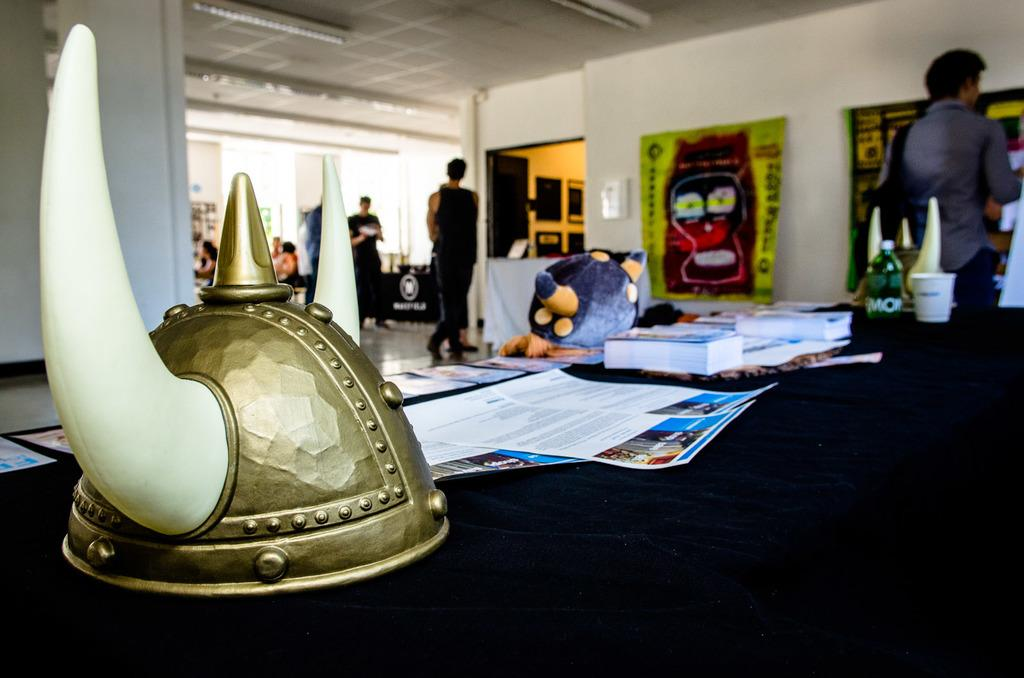What type of hat is in the image? There is a hat with two horns in the image. Where is the hat located? The hat is placed on a table. What other items can be seen on the table? There are books, papers, a bottle, and a cup on the table. Are there any people visible in the image? Yes, there are people standing in the background of the image. What type of jelly is being smashed by the hat in the image? There is no jelly or smashing activity present in the image. 